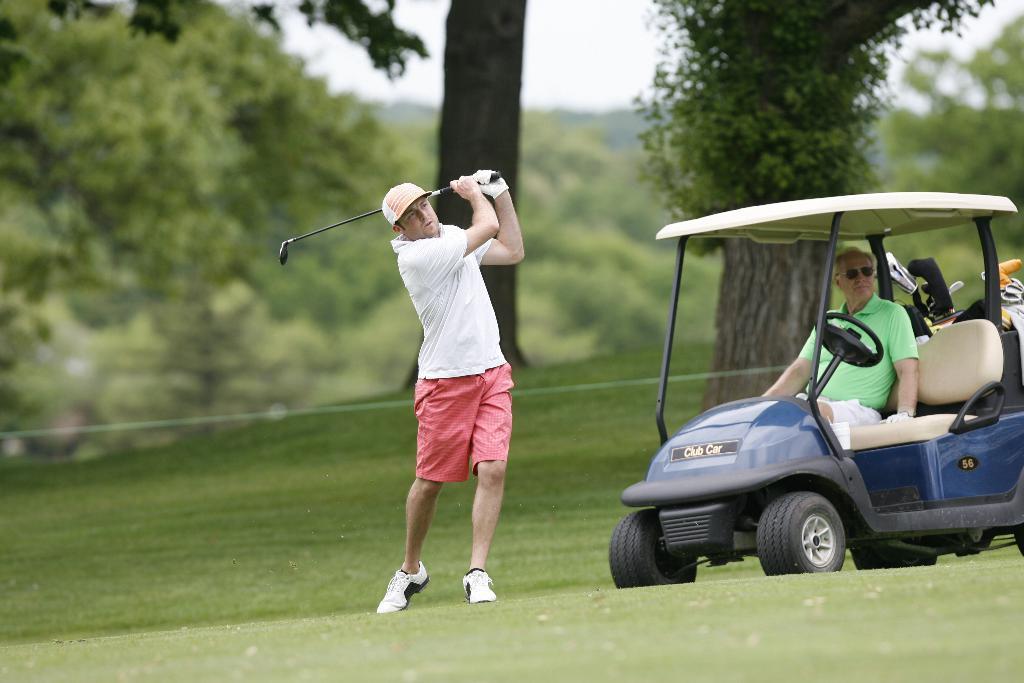In one or two sentences, can you explain what this image depicts? There is a vehicle on the ground. Here we can see two persons and he is holding a bat with his hands. In the background we can see trees and sky. 